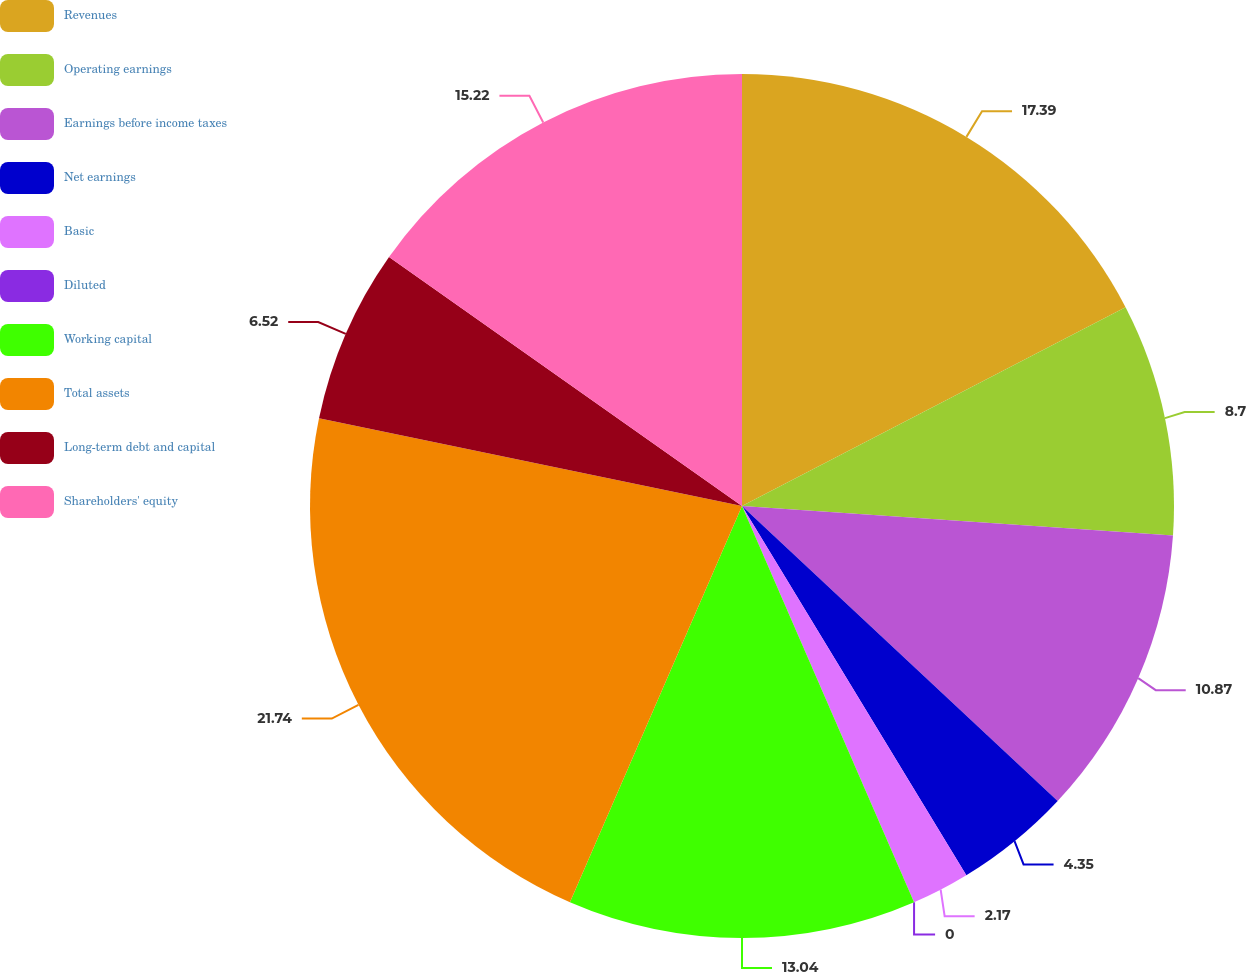<chart> <loc_0><loc_0><loc_500><loc_500><pie_chart><fcel>Revenues<fcel>Operating earnings<fcel>Earnings before income taxes<fcel>Net earnings<fcel>Basic<fcel>Diluted<fcel>Working capital<fcel>Total assets<fcel>Long-term debt and capital<fcel>Shareholders' equity<nl><fcel>17.39%<fcel>8.7%<fcel>10.87%<fcel>4.35%<fcel>2.17%<fcel>0.0%<fcel>13.04%<fcel>21.74%<fcel>6.52%<fcel>15.22%<nl></chart> 